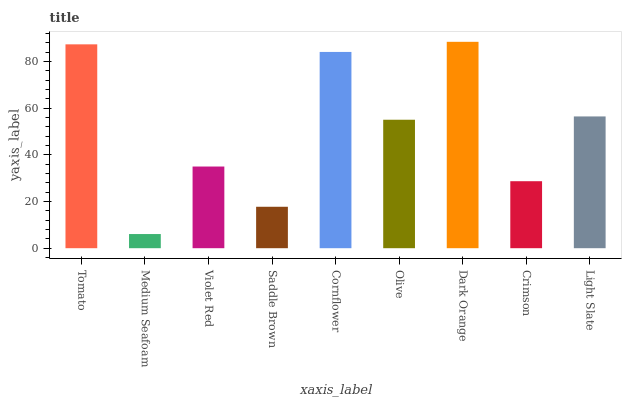Is Medium Seafoam the minimum?
Answer yes or no. Yes. Is Dark Orange the maximum?
Answer yes or no. Yes. Is Violet Red the minimum?
Answer yes or no. No. Is Violet Red the maximum?
Answer yes or no. No. Is Violet Red greater than Medium Seafoam?
Answer yes or no. Yes. Is Medium Seafoam less than Violet Red?
Answer yes or no. Yes. Is Medium Seafoam greater than Violet Red?
Answer yes or no. No. Is Violet Red less than Medium Seafoam?
Answer yes or no. No. Is Olive the high median?
Answer yes or no. Yes. Is Olive the low median?
Answer yes or no. Yes. Is Crimson the high median?
Answer yes or no. No. Is Cornflower the low median?
Answer yes or no. No. 